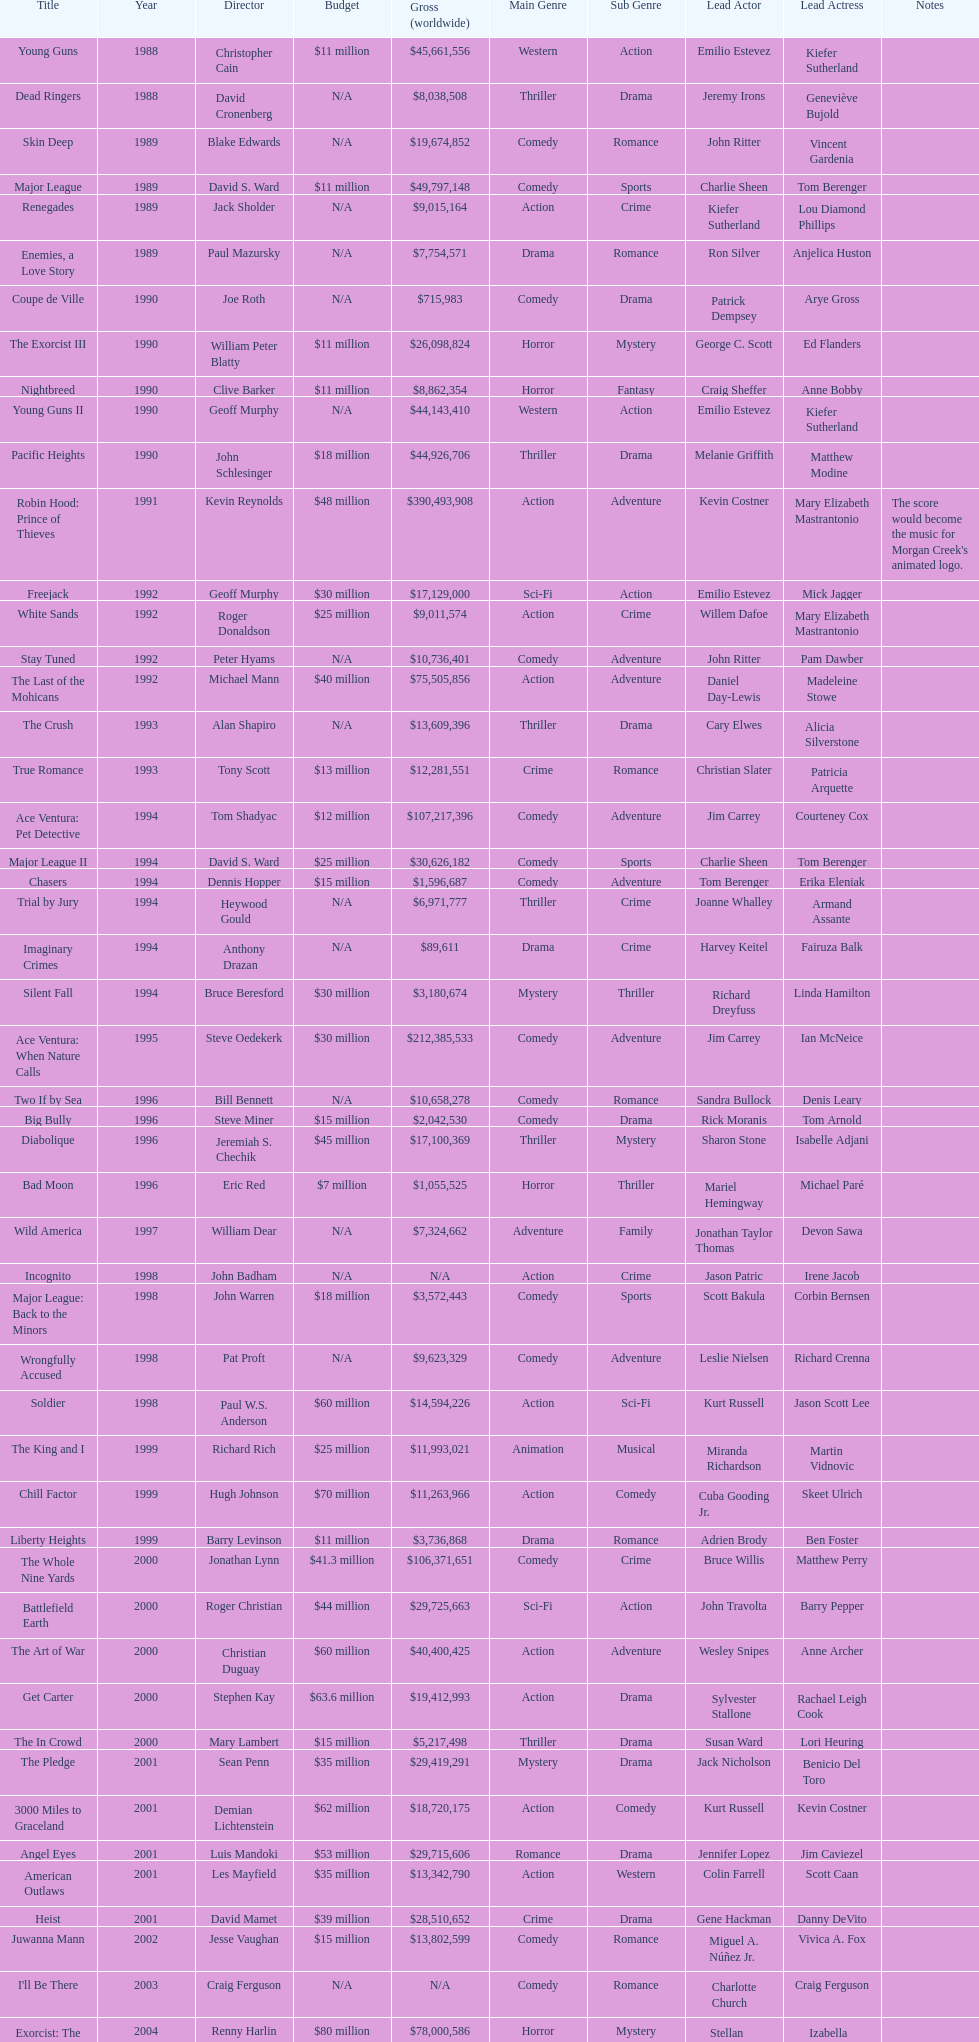What was the last movie morgan creek made for a budget under thirty million? Ace Ventura Jr: Pet Detective. 